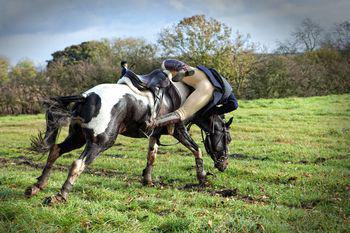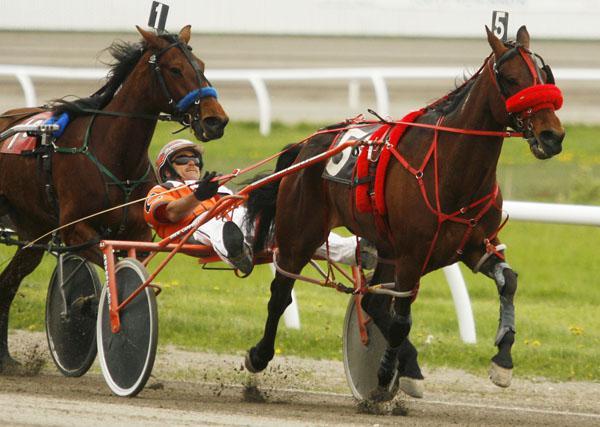The first image is the image on the left, the second image is the image on the right. Examine the images to the left and right. Is the description "There are exactly three horses." accurate? Answer yes or no. Yes. The first image is the image on the left, the second image is the image on the right. Examine the images to the left and right. Is the description "A man in a helmet is being pulled by at least one horse." accurate? Answer yes or no. Yes. 